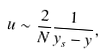<formula> <loc_0><loc_0><loc_500><loc_500>u \sim \frac { 2 } { N } \frac { 1 } { y _ { s } - y } ,</formula> 